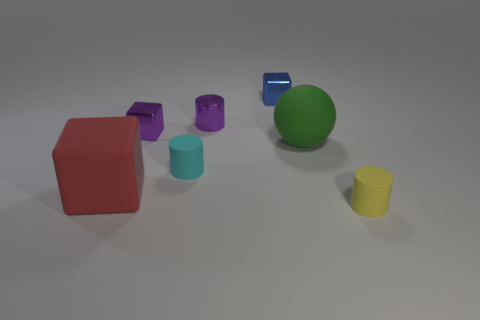Add 1 large green rubber balls. How many objects exist? 8 Subtract all balls. How many objects are left? 6 Add 3 tiny shiny objects. How many tiny shiny objects exist? 6 Subtract 1 purple blocks. How many objects are left? 6 Subtract all rubber cylinders. Subtract all big green objects. How many objects are left? 4 Add 1 shiny blocks. How many shiny blocks are left? 3 